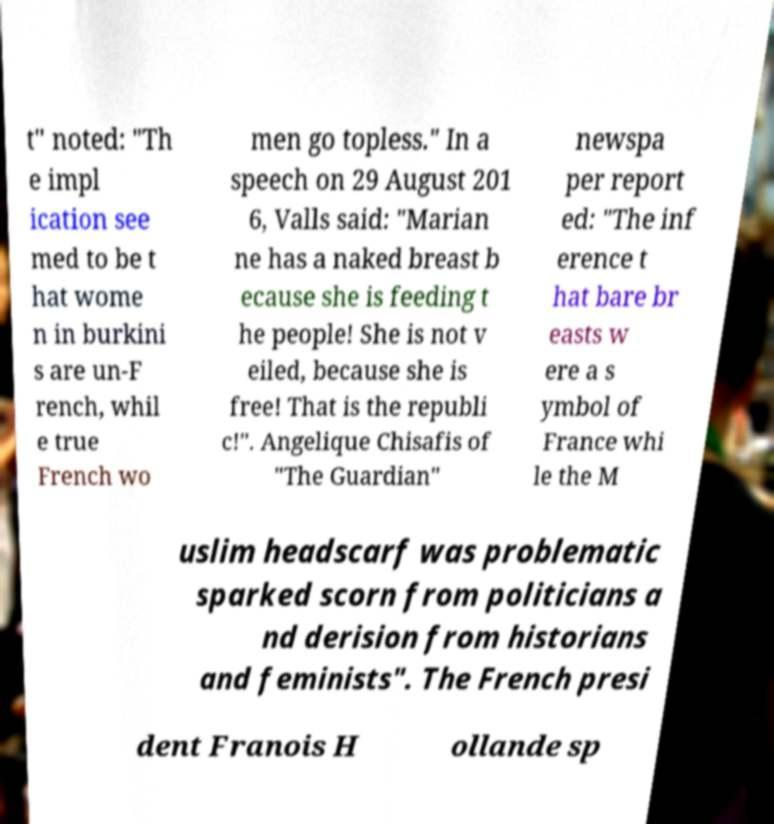Can you read and provide the text displayed in the image?This photo seems to have some interesting text. Can you extract and type it out for me? t" noted: "Th e impl ication see med to be t hat wome n in burkini s are un-F rench, whil e true French wo men go topless." In a speech on 29 August 201 6, Valls said: "Marian ne has a naked breast b ecause she is feeding t he people! She is not v eiled, because she is free! That is the republi c!". Angelique Chisafis of "The Guardian" newspa per report ed: "The inf erence t hat bare br easts w ere a s ymbol of France whi le the M uslim headscarf was problematic sparked scorn from politicians a nd derision from historians and feminists". The French presi dent Franois H ollande sp 